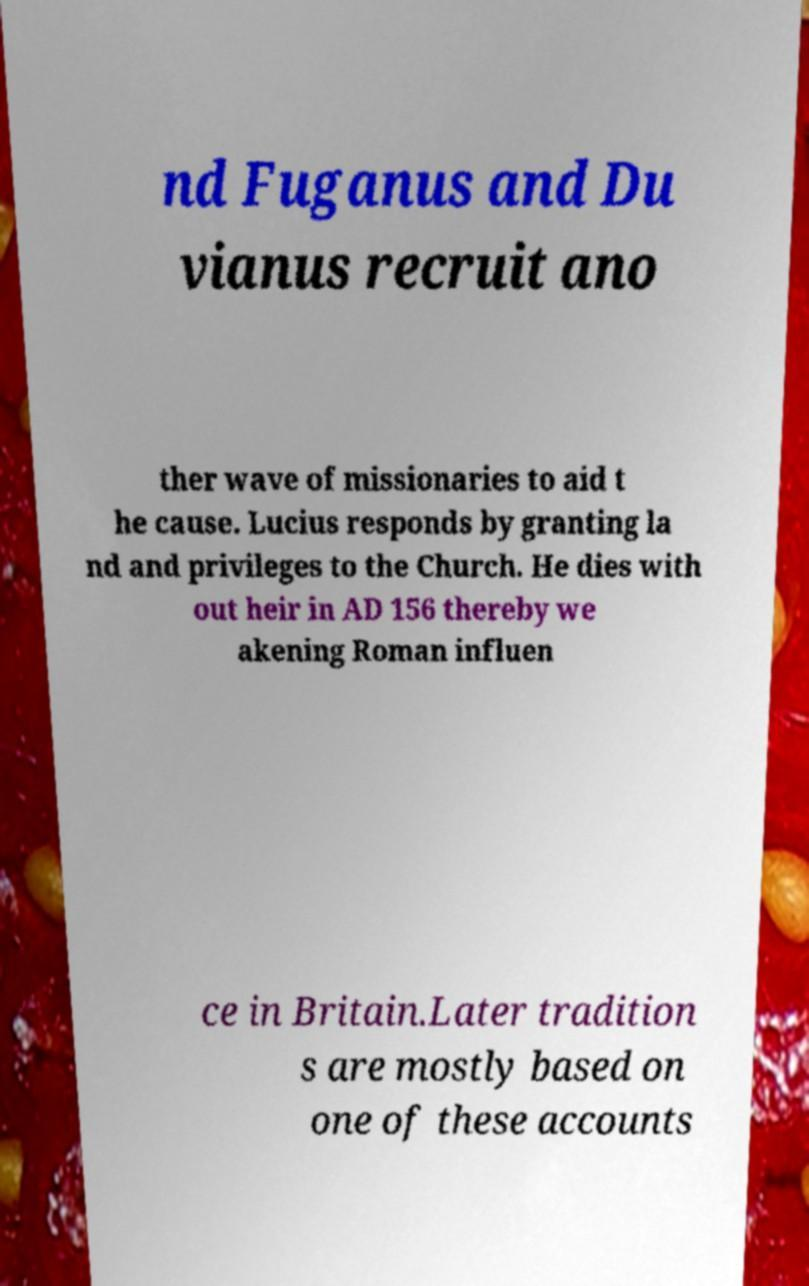Could you extract and type out the text from this image? nd Fuganus and Du vianus recruit ano ther wave of missionaries to aid t he cause. Lucius responds by granting la nd and privileges to the Church. He dies with out heir in AD 156 thereby we akening Roman influen ce in Britain.Later tradition s are mostly based on one of these accounts 